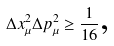Convert formula to latex. <formula><loc_0><loc_0><loc_500><loc_500>\Delta x _ { \mu } ^ { 2 } \Delta p _ { \mu } ^ { 2 } \geq \frac { 1 } { 1 6 } \text {,}</formula> 